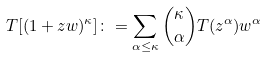<formula> <loc_0><loc_0><loc_500><loc_500>T [ ( 1 + z w ) ^ { \kappa } ] \colon = \sum _ { \alpha \leq \kappa } \binom { \kappa } { \alpha } T ( z ^ { \alpha } ) w ^ { \alpha }</formula> 